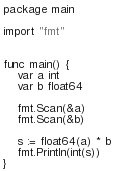Convert code to text. <code><loc_0><loc_0><loc_500><loc_500><_Go_>package main

import "fmt"


func main() {
	var a int
  	var b float64
  
  	fmt.Scan(&a)
  	fmt.Scan(&b)
  
  	s := float64(a) * b
  	fmt.Println(int(s))
}</code> 